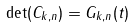<formula> <loc_0><loc_0><loc_500><loc_500>\det ( C _ { k , n } ) = G _ { k , n } ( t )</formula> 